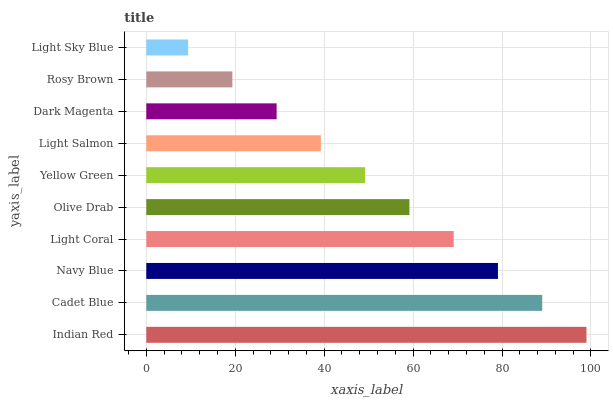Is Light Sky Blue the minimum?
Answer yes or no. Yes. Is Indian Red the maximum?
Answer yes or no. Yes. Is Cadet Blue the minimum?
Answer yes or no. No. Is Cadet Blue the maximum?
Answer yes or no. No. Is Indian Red greater than Cadet Blue?
Answer yes or no. Yes. Is Cadet Blue less than Indian Red?
Answer yes or no. Yes. Is Cadet Blue greater than Indian Red?
Answer yes or no. No. Is Indian Red less than Cadet Blue?
Answer yes or no. No. Is Olive Drab the high median?
Answer yes or no. Yes. Is Yellow Green the low median?
Answer yes or no. Yes. Is Yellow Green the high median?
Answer yes or no. No. Is Light Salmon the low median?
Answer yes or no. No. 